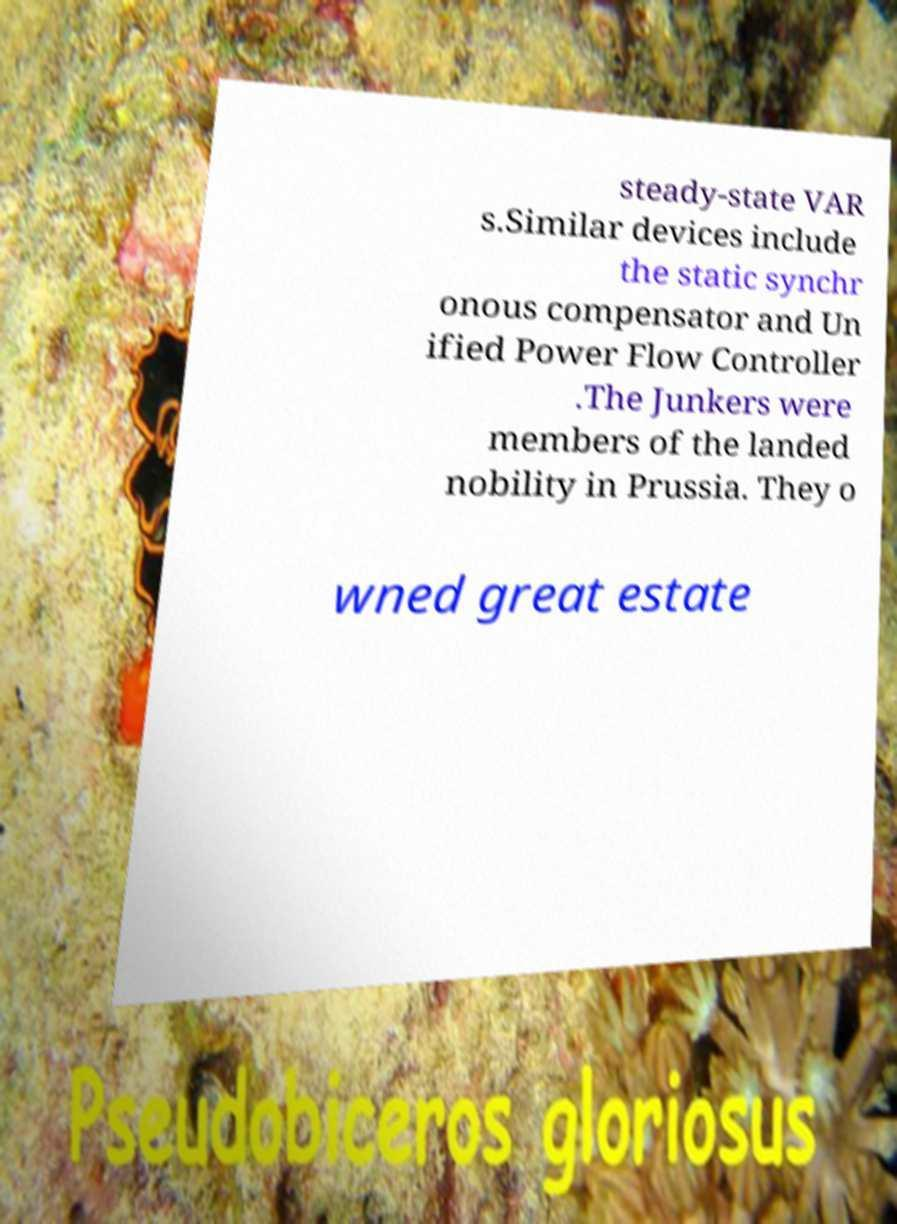Can you accurately transcribe the text from the provided image for me? steady-state VAR s.Similar devices include the static synchr onous compensator and Un ified Power Flow Controller .The Junkers were members of the landed nobility in Prussia. They o wned great estate 